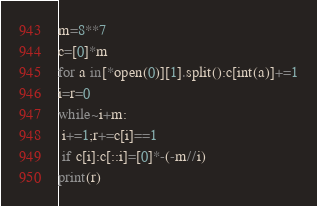<code> <loc_0><loc_0><loc_500><loc_500><_Cython_>m=8**7
c=[0]*m
for a in[*open(0)][1].split():c[int(a)]+=1
i=r=0
while~i+m:
 i+=1;r+=c[i]==1
 if c[i]:c[::i]=[0]*-(-m//i)
print(r)</code> 